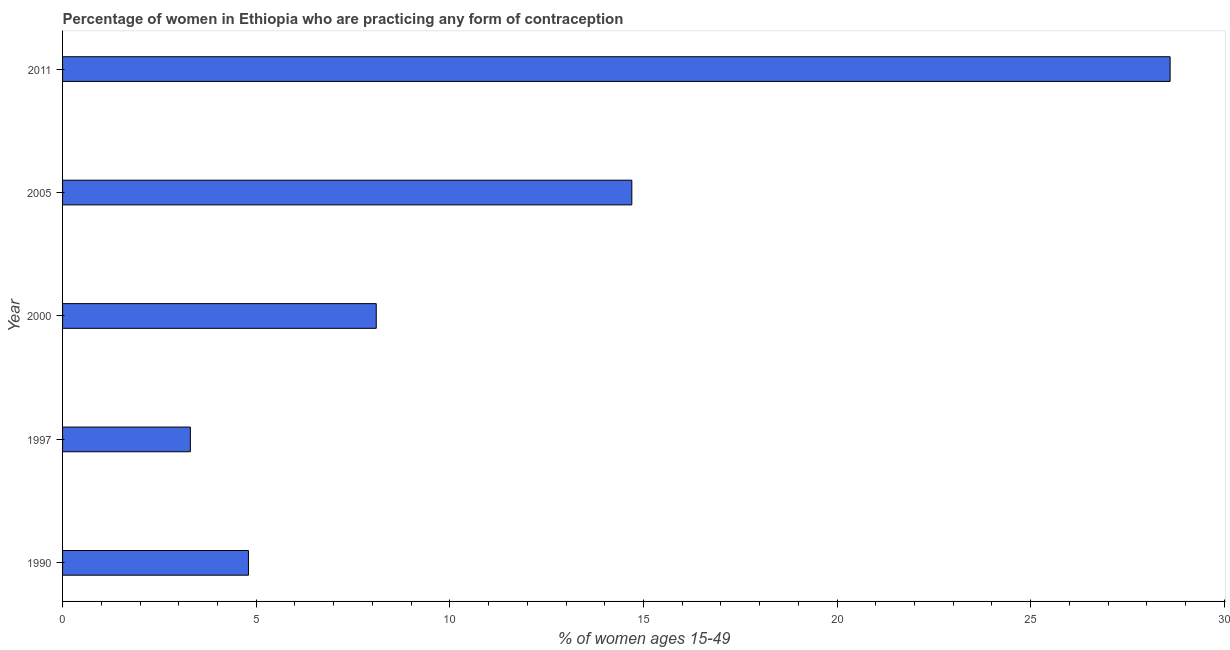Does the graph contain any zero values?
Make the answer very short. No. Does the graph contain grids?
Your answer should be compact. No. What is the title of the graph?
Provide a succinct answer. Percentage of women in Ethiopia who are practicing any form of contraception. What is the label or title of the X-axis?
Ensure brevity in your answer.  % of women ages 15-49. What is the contraceptive prevalence in 1990?
Make the answer very short. 4.8. Across all years, what is the maximum contraceptive prevalence?
Your answer should be very brief. 28.6. Across all years, what is the minimum contraceptive prevalence?
Make the answer very short. 3.3. What is the sum of the contraceptive prevalence?
Provide a short and direct response. 59.5. What is the median contraceptive prevalence?
Offer a very short reply. 8.1. What is the ratio of the contraceptive prevalence in 1990 to that in 1997?
Offer a very short reply. 1.46. Is the sum of the contraceptive prevalence in 1997 and 2000 greater than the maximum contraceptive prevalence across all years?
Provide a succinct answer. No. What is the difference between the highest and the lowest contraceptive prevalence?
Your answer should be very brief. 25.3. What is the % of women ages 15-49 of 1990?
Make the answer very short. 4.8. What is the % of women ages 15-49 in 1997?
Offer a very short reply. 3.3. What is the % of women ages 15-49 of 2000?
Make the answer very short. 8.1. What is the % of women ages 15-49 of 2005?
Provide a succinct answer. 14.7. What is the % of women ages 15-49 in 2011?
Your answer should be compact. 28.6. What is the difference between the % of women ages 15-49 in 1990 and 1997?
Offer a very short reply. 1.5. What is the difference between the % of women ages 15-49 in 1990 and 2000?
Your response must be concise. -3.3. What is the difference between the % of women ages 15-49 in 1990 and 2011?
Offer a terse response. -23.8. What is the difference between the % of women ages 15-49 in 1997 and 2000?
Provide a short and direct response. -4.8. What is the difference between the % of women ages 15-49 in 1997 and 2011?
Your response must be concise. -25.3. What is the difference between the % of women ages 15-49 in 2000 and 2005?
Your answer should be very brief. -6.6. What is the difference between the % of women ages 15-49 in 2000 and 2011?
Offer a terse response. -20.5. What is the ratio of the % of women ages 15-49 in 1990 to that in 1997?
Provide a short and direct response. 1.46. What is the ratio of the % of women ages 15-49 in 1990 to that in 2000?
Your response must be concise. 0.59. What is the ratio of the % of women ages 15-49 in 1990 to that in 2005?
Provide a succinct answer. 0.33. What is the ratio of the % of women ages 15-49 in 1990 to that in 2011?
Your response must be concise. 0.17. What is the ratio of the % of women ages 15-49 in 1997 to that in 2000?
Give a very brief answer. 0.41. What is the ratio of the % of women ages 15-49 in 1997 to that in 2005?
Make the answer very short. 0.22. What is the ratio of the % of women ages 15-49 in 1997 to that in 2011?
Keep it short and to the point. 0.12. What is the ratio of the % of women ages 15-49 in 2000 to that in 2005?
Keep it short and to the point. 0.55. What is the ratio of the % of women ages 15-49 in 2000 to that in 2011?
Provide a short and direct response. 0.28. What is the ratio of the % of women ages 15-49 in 2005 to that in 2011?
Make the answer very short. 0.51. 